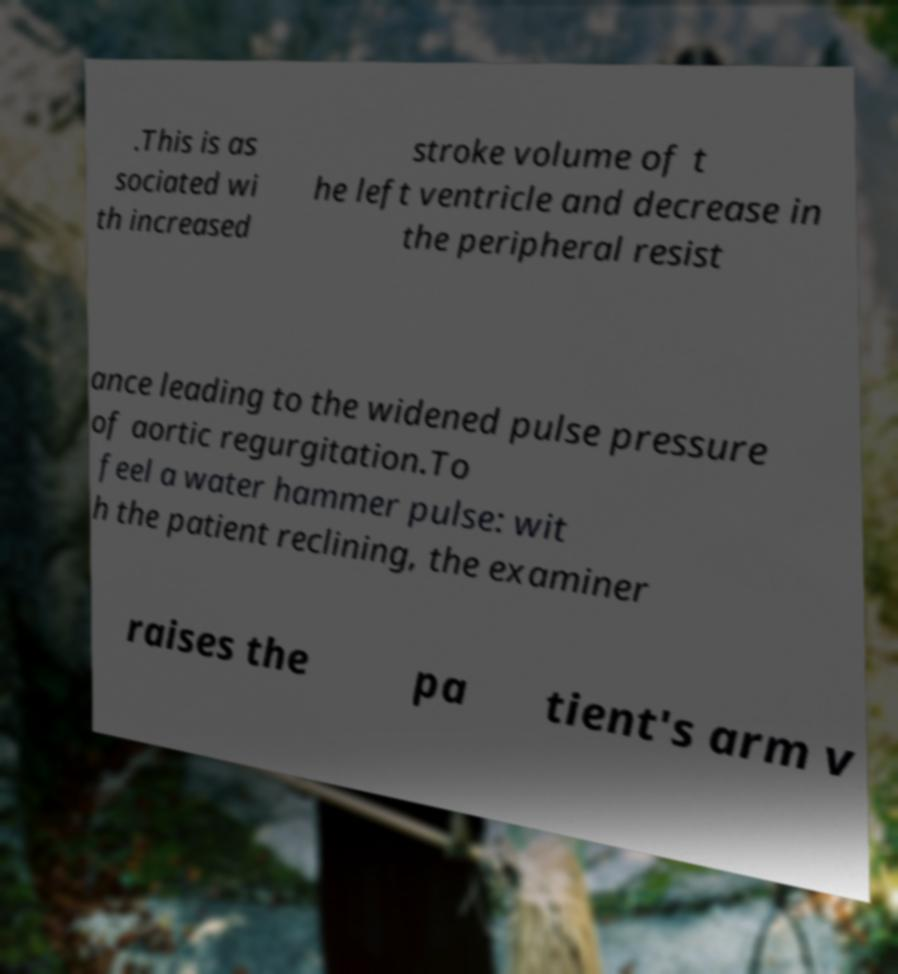Could you assist in decoding the text presented in this image and type it out clearly? .This is as sociated wi th increased stroke volume of t he left ventricle and decrease in the peripheral resist ance leading to the widened pulse pressure of aortic regurgitation.To feel a water hammer pulse: wit h the patient reclining, the examiner raises the pa tient's arm v 